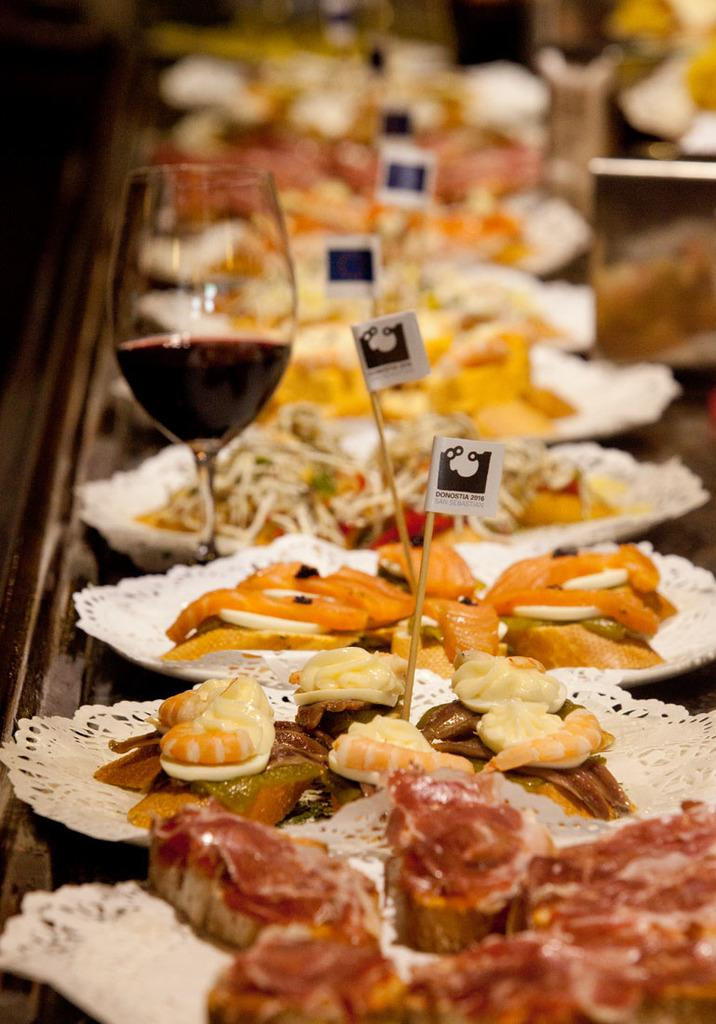What type of furniture is visible in the image? There is a table in the image. What type of food is present on the table? There are plates of salad in the image. What type of meat can be seen in the image? There is meat in the image. What utensils are used to hold the food in the image? Toothpicks are present in the image. What type of beverage is in the glass in the image? There is a glass with wine in the image. Can you see a pump in the image? There is no pump present in the image. Are there any cows or rabbits visible in the image? No, there are no cows or rabbits present in the image. 